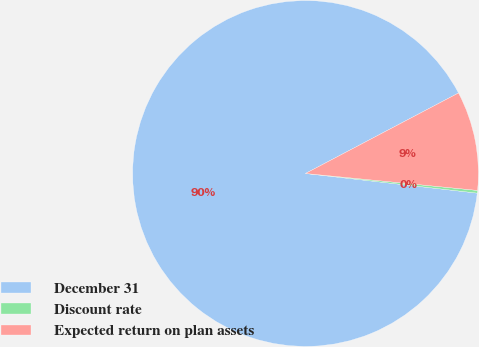Convert chart to OTSL. <chart><loc_0><loc_0><loc_500><loc_500><pie_chart><fcel>December 31<fcel>Discount rate<fcel>Expected return on plan assets<nl><fcel>90.48%<fcel>0.25%<fcel>9.27%<nl></chart> 